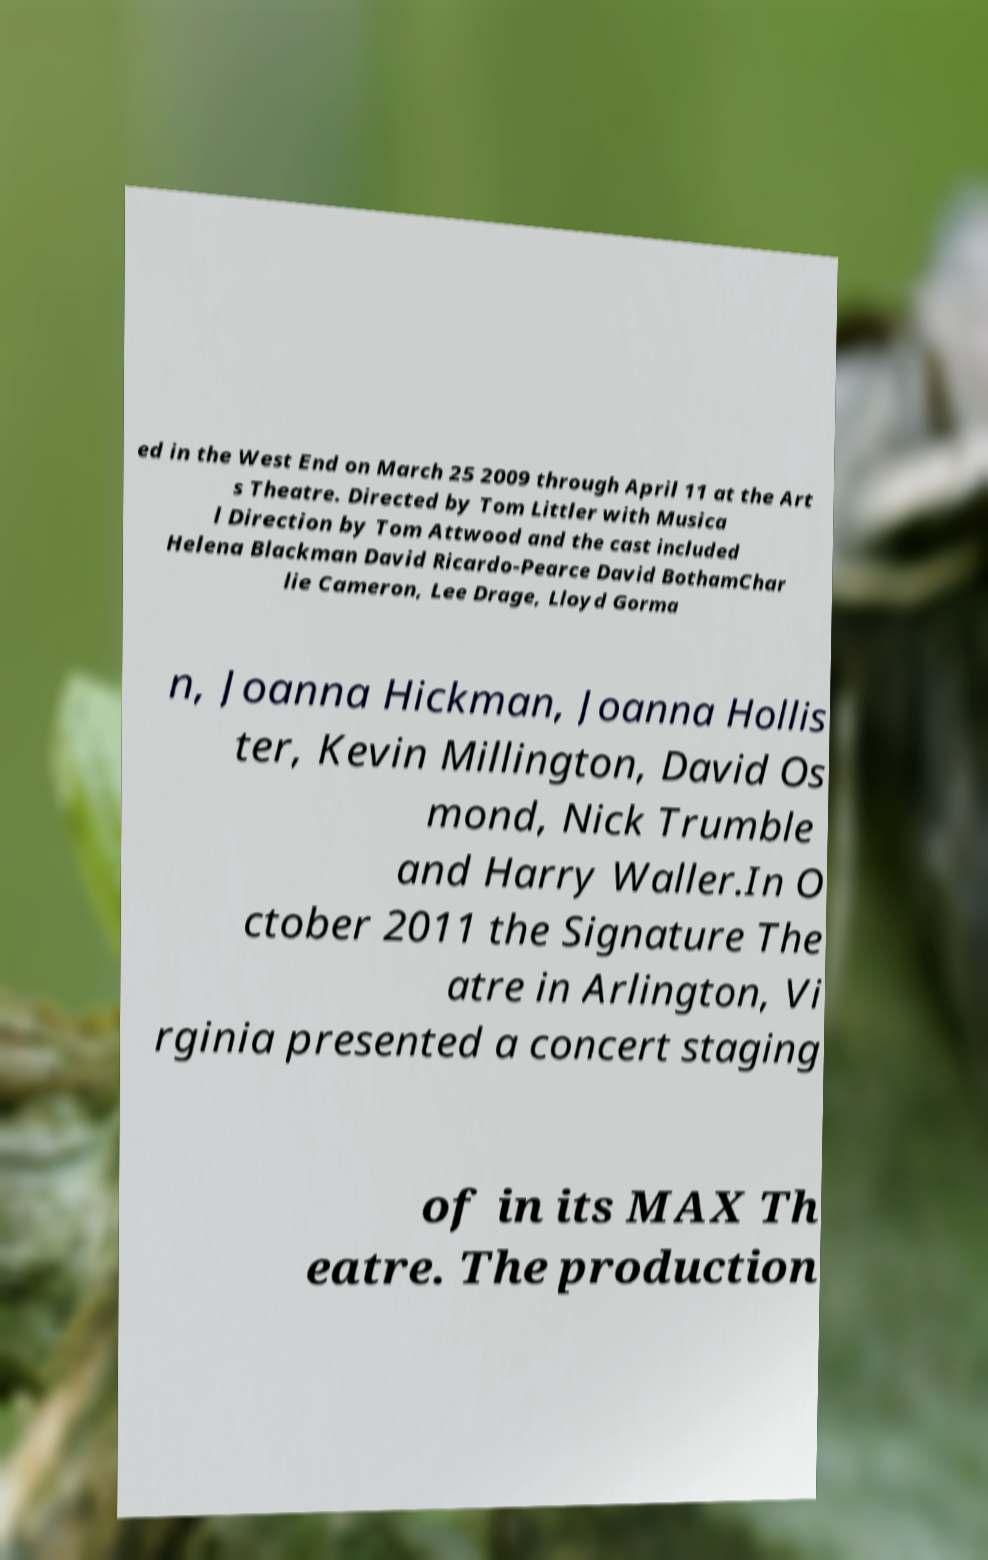I need the written content from this picture converted into text. Can you do that? ed in the West End on March 25 2009 through April 11 at the Art s Theatre. Directed by Tom Littler with Musica l Direction by Tom Attwood and the cast included Helena Blackman David Ricardo-Pearce David BothamChar lie Cameron, Lee Drage, Lloyd Gorma n, Joanna Hickman, Joanna Hollis ter, Kevin Millington, David Os mond, Nick Trumble and Harry Waller.In O ctober 2011 the Signature The atre in Arlington, Vi rginia presented a concert staging of in its MAX Th eatre. The production 